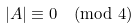<formula> <loc_0><loc_0><loc_500><loc_500>| A | \equiv 0 \pmod { 4 }</formula> 